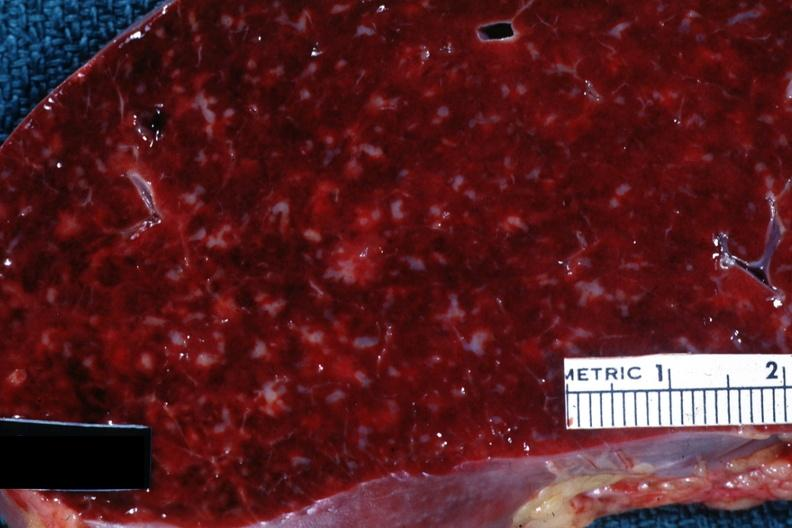how does this image show close-up?
Answer the question using a single word or phrase. With obvious small infiltrates of something 